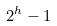<formula> <loc_0><loc_0><loc_500><loc_500>2 ^ { h } - 1</formula> 